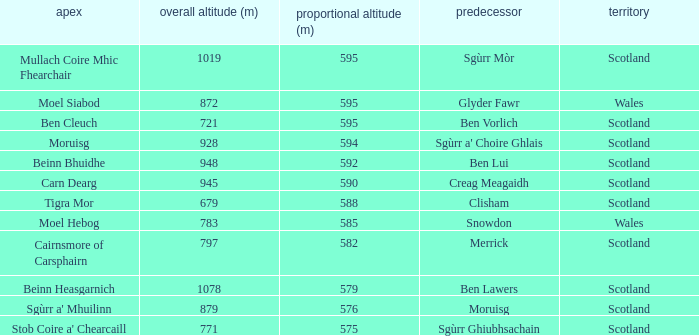What is the relative height of Scotland with Ben Vorlich as parent? 1.0. 